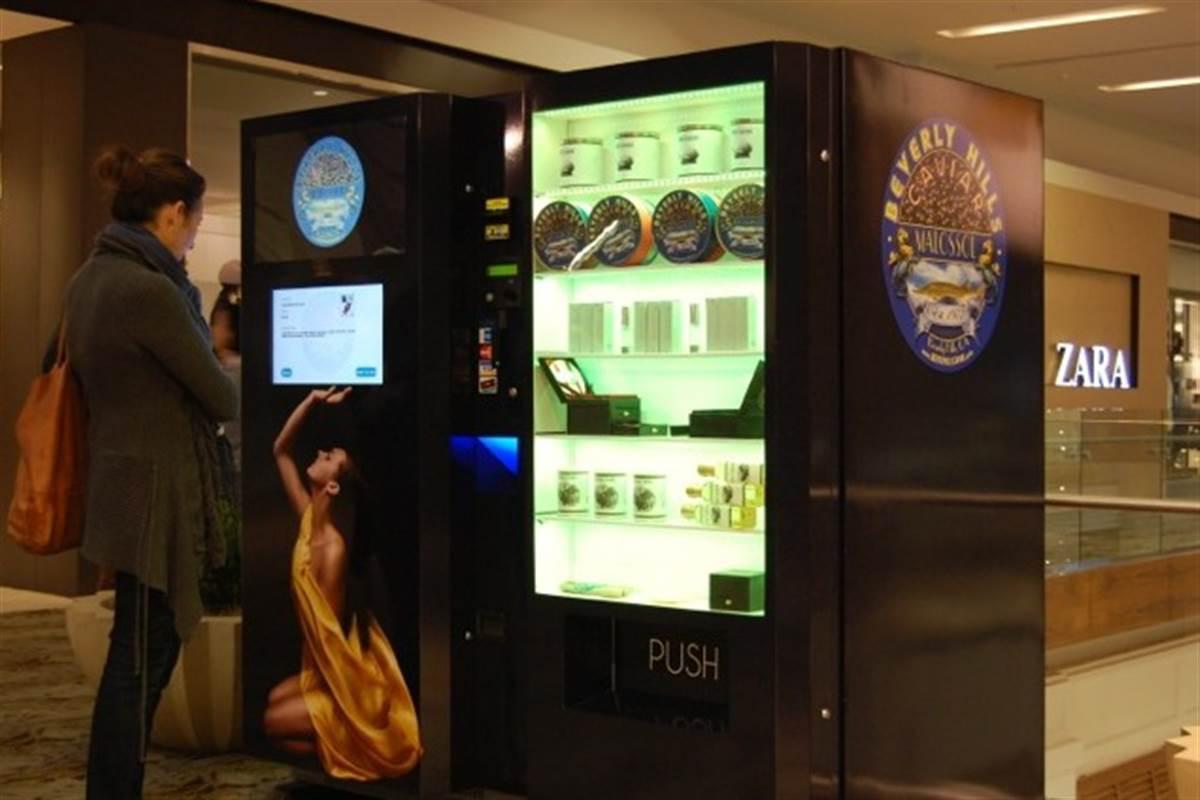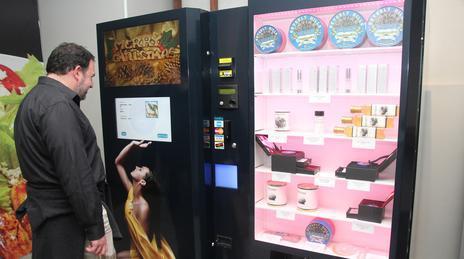The first image is the image on the left, the second image is the image on the right. Considering the images on both sides, is "At least one image shows at least one person standing in front of a vending machine." valid? Answer yes or no. Yes. The first image is the image on the left, the second image is the image on the right. For the images displayed, is the sentence "One of the images has a male looking directly at the machine." factually correct? Answer yes or no. Yes. 